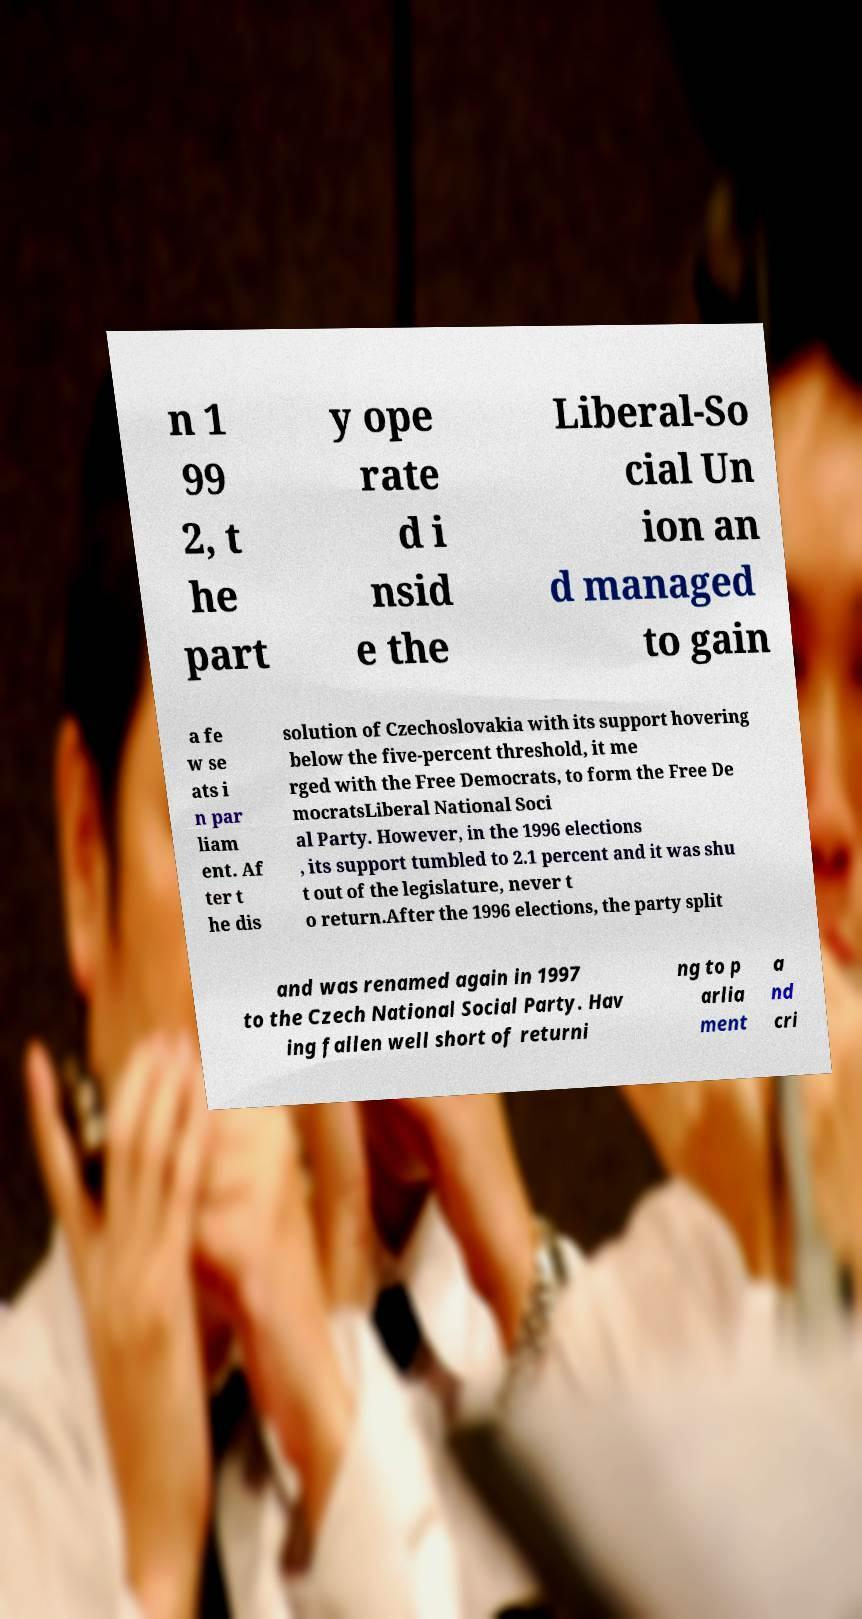What messages or text are displayed in this image? I need them in a readable, typed format. n 1 99 2, t he part y ope rate d i nsid e the Liberal-So cial Un ion an d managed to gain a fe w se ats i n par liam ent. Af ter t he dis solution of Czechoslovakia with its support hovering below the five-percent threshold, it me rged with the Free Democrats, to form the Free De mocratsLiberal National Soci al Party. However, in the 1996 elections , its support tumbled to 2.1 percent and it was shu t out of the legislature, never t o return.After the 1996 elections, the party split and was renamed again in 1997 to the Czech National Social Party. Hav ing fallen well short of returni ng to p arlia ment a nd cri 